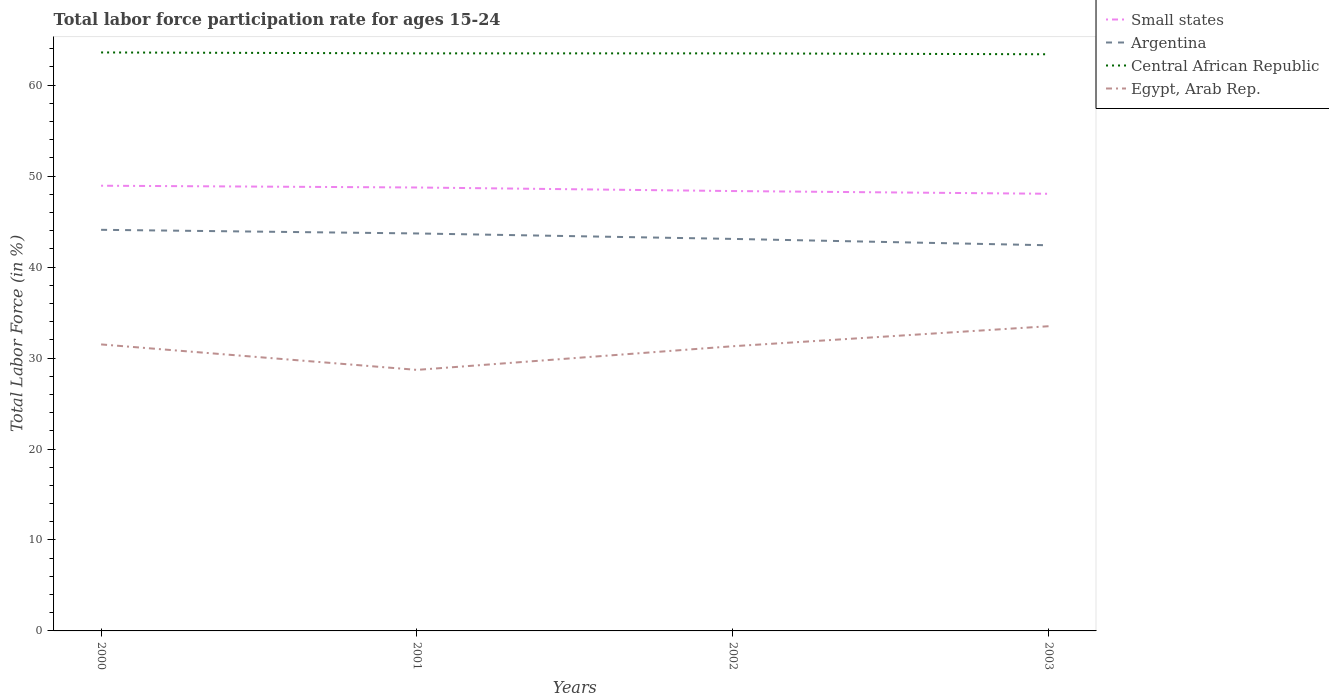How many different coloured lines are there?
Offer a terse response. 4. Does the line corresponding to Small states intersect with the line corresponding to Egypt, Arab Rep.?
Your answer should be very brief. No. Is the number of lines equal to the number of legend labels?
Make the answer very short. Yes. Across all years, what is the maximum labor force participation rate in Small states?
Offer a very short reply. 48.06. In which year was the labor force participation rate in Central African Republic maximum?
Your answer should be compact. 2003. What is the total labor force participation rate in Small states in the graph?
Your answer should be very brief. 0.59. What is the difference between the highest and the second highest labor force participation rate in Central African Republic?
Give a very brief answer. 0.2. Is the labor force participation rate in Central African Republic strictly greater than the labor force participation rate in Argentina over the years?
Your response must be concise. No. How many years are there in the graph?
Make the answer very short. 4. Are the values on the major ticks of Y-axis written in scientific E-notation?
Your answer should be compact. No. Where does the legend appear in the graph?
Offer a very short reply. Top right. How many legend labels are there?
Provide a short and direct response. 4. What is the title of the graph?
Keep it short and to the point. Total labor force participation rate for ages 15-24. What is the label or title of the X-axis?
Provide a short and direct response. Years. What is the Total Labor Force (in %) in Small states in 2000?
Make the answer very short. 48.95. What is the Total Labor Force (in %) of Argentina in 2000?
Your answer should be compact. 44.1. What is the Total Labor Force (in %) of Central African Republic in 2000?
Provide a short and direct response. 63.6. What is the Total Labor Force (in %) in Egypt, Arab Rep. in 2000?
Make the answer very short. 31.5. What is the Total Labor Force (in %) in Small states in 2001?
Keep it short and to the point. 48.75. What is the Total Labor Force (in %) of Argentina in 2001?
Give a very brief answer. 43.7. What is the Total Labor Force (in %) in Central African Republic in 2001?
Your answer should be compact. 63.5. What is the Total Labor Force (in %) of Egypt, Arab Rep. in 2001?
Your answer should be very brief. 28.7. What is the Total Labor Force (in %) in Small states in 2002?
Give a very brief answer. 48.36. What is the Total Labor Force (in %) in Argentina in 2002?
Give a very brief answer. 43.1. What is the Total Labor Force (in %) in Central African Republic in 2002?
Make the answer very short. 63.5. What is the Total Labor Force (in %) of Egypt, Arab Rep. in 2002?
Provide a short and direct response. 31.3. What is the Total Labor Force (in %) in Small states in 2003?
Your answer should be very brief. 48.06. What is the Total Labor Force (in %) in Argentina in 2003?
Provide a short and direct response. 42.4. What is the Total Labor Force (in %) in Central African Republic in 2003?
Offer a very short reply. 63.4. What is the Total Labor Force (in %) of Egypt, Arab Rep. in 2003?
Keep it short and to the point. 33.5. Across all years, what is the maximum Total Labor Force (in %) of Small states?
Ensure brevity in your answer.  48.95. Across all years, what is the maximum Total Labor Force (in %) in Argentina?
Provide a succinct answer. 44.1. Across all years, what is the maximum Total Labor Force (in %) of Central African Republic?
Your answer should be very brief. 63.6. Across all years, what is the maximum Total Labor Force (in %) of Egypt, Arab Rep.?
Your response must be concise. 33.5. Across all years, what is the minimum Total Labor Force (in %) of Small states?
Your answer should be compact. 48.06. Across all years, what is the minimum Total Labor Force (in %) in Argentina?
Your response must be concise. 42.4. Across all years, what is the minimum Total Labor Force (in %) in Central African Republic?
Ensure brevity in your answer.  63.4. Across all years, what is the minimum Total Labor Force (in %) of Egypt, Arab Rep.?
Your response must be concise. 28.7. What is the total Total Labor Force (in %) in Small states in the graph?
Offer a terse response. 194.12. What is the total Total Labor Force (in %) of Argentina in the graph?
Offer a terse response. 173.3. What is the total Total Labor Force (in %) of Central African Republic in the graph?
Offer a very short reply. 254. What is the total Total Labor Force (in %) of Egypt, Arab Rep. in the graph?
Your answer should be compact. 125. What is the difference between the Total Labor Force (in %) in Small states in 2000 and that in 2001?
Offer a terse response. 0.19. What is the difference between the Total Labor Force (in %) in Egypt, Arab Rep. in 2000 and that in 2001?
Ensure brevity in your answer.  2.8. What is the difference between the Total Labor Force (in %) of Small states in 2000 and that in 2002?
Your answer should be very brief. 0.59. What is the difference between the Total Labor Force (in %) of Central African Republic in 2000 and that in 2002?
Your answer should be very brief. 0.1. What is the difference between the Total Labor Force (in %) in Egypt, Arab Rep. in 2000 and that in 2002?
Offer a very short reply. 0.2. What is the difference between the Total Labor Force (in %) of Small states in 2000 and that in 2003?
Provide a succinct answer. 0.89. What is the difference between the Total Labor Force (in %) of Egypt, Arab Rep. in 2000 and that in 2003?
Your answer should be very brief. -2. What is the difference between the Total Labor Force (in %) in Small states in 2001 and that in 2002?
Your response must be concise. 0.39. What is the difference between the Total Labor Force (in %) in Central African Republic in 2001 and that in 2002?
Keep it short and to the point. 0. What is the difference between the Total Labor Force (in %) of Egypt, Arab Rep. in 2001 and that in 2002?
Offer a terse response. -2.6. What is the difference between the Total Labor Force (in %) of Small states in 2001 and that in 2003?
Offer a terse response. 0.69. What is the difference between the Total Labor Force (in %) of Small states in 2002 and that in 2003?
Ensure brevity in your answer.  0.3. What is the difference between the Total Labor Force (in %) in Egypt, Arab Rep. in 2002 and that in 2003?
Provide a succinct answer. -2.2. What is the difference between the Total Labor Force (in %) of Small states in 2000 and the Total Labor Force (in %) of Argentina in 2001?
Offer a terse response. 5.25. What is the difference between the Total Labor Force (in %) in Small states in 2000 and the Total Labor Force (in %) in Central African Republic in 2001?
Provide a succinct answer. -14.55. What is the difference between the Total Labor Force (in %) in Small states in 2000 and the Total Labor Force (in %) in Egypt, Arab Rep. in 2001?
Keep it short and to the point. 20.25. What is the difference between the Total Labor Force (in %) in Argentina in 2000 and the Total Labor Force (in %) in Central African Republic in 2001?
Give a very brief answer. -19.4. What is the difference between the Total Labor Force (in %) of Argentina in 2000 and the Total Labor Force (in %) of Egypt, Arab Rep. in 2001?
Provide a short and direct response. 15.4. What is the difference between the Total Labor Force (in %) in Central African Republic in 2000 and the Total Labor Force (in %) in Egypt, Arab Rep. in 2001?
Give a very brief answer. 34.9. What is the difference between the Total Labor Force (in %) in Small states in 2000 and the Total Labor Force (in %) in Argentina in 2002?
Keep it short and to the point. 5.85. What is the difference between the Total Labor Force (in %) of Small states in 2000 and the Total Labor Force (in %) of Central African Republic in 2002?
Provide a succinct answer. -14.55. What is the difference between the Total Labor Force (in %) in Small states in 2000 and the Total Labor Force (in %) in Egypt, Arab Rep. in 2002?
Your answer should be compact. 17.65. What is the difference between the Total Labor Force (in %) of Argentina in 2000 and the Total Labor Force (in %) of Central African Republic in 2002?
Keep it short and to the point. -19.4. What is the difference between the Total Labor Force (in %) in Central African Republic in 2000 and the Total Labor Force (in %) in Egypt, Arab Rep. in 2002?
Offer a terse response. 32.3. What is the difference between the Total Labor Force (in %) of Small states in 2000 and the Total Labor Force (in %) of Argentina in 2003?
Offer a very short reply. 6.55. What is the difference between the Total Labor Force (in %) in Small states in 2000 and the Total Labor Force (in %) in Central African Republic in 2003?
Provide a short and direct response. -14.45. What is the difference between the Total Labor Force (in %) of Small states in 2000 and the Total Labor Force (in %) of Egypt, Arab Rep. in 2003?
Offer a terse response. 15.45. What is the difference between the Total Labor Force (in %) in Argentina in 2000 and the Total Labor Force (in %) in Central African Republic in 2003?
Give a very brief answer. -19.3. What is the difference between the Total Labor Force (in %) of Argentina in 2000 and the Total Labor Force (in %) of Egypt, Arab Rep. in 2003?
Offer a very short reply. 10.6. What is the difference between the Total Labor Force (in %) of Central African Republic in 2000 and the Total Labor Force (in %) of Egypt, Arab Rep. in 2003?
Your answer should be very brief. 30.1. What is the difference between the Total Labor Force (in %) in Small states in 2001 and the Total Labor Force (in %) in Argentina in 2002?
Ensure brevity in your answer.  5.65. What is the difference between the Total Labor Force (in %) of Small states in 2001 and the Total Labor Force (in %) of Central African Republic in 2002?
Provide a succinct answer. -14.75. What is the difference between the Total Labor Force (in %) in Small states in 2001 and the Total Labor Force (in %) in Egypt, Arab Rep. in 2002?
Offer a terse response. 17.45. What is the difference between the Total Labor Force (in %) in Argentina in 2001 and the Total Labor Force (in %) in Central African Republic in 2002?
Your answer should be compact. -19.8. What is the difference between the Total Labor Force (in %) of Central African Republic in 2001 and the Total Labor Force (in %) of Egypt, Arab Rep. in 2002?
Make the answer very short. 32.2. What is the difference between the Total Labor Force (in %) in Small states in 2001 and the Total Labor Force (in %) in Argentina in 2003?
Your answer should be very brief. 6.35. What is the difference between the Total Labor Force (in %) of Small states in 2001 and the Total Labor Force (in %) of Central African Republic in 2003?
Give a very brief answer. -14.65. What is the difference between the Total Labor Force (in %) in Small states in 2001 and the Total Labor Force (in %) in Egypt, Arab Rep. in 2003?
Offer a very short reply. 15.25. What is the difference between the Total Labor Force (in %) in Argentina in 2001 and the Total Labor Force (in %) in Central African Republic in 2003?
Ensure brevity in your answer.  -19.7. What is the difference between the Total Labor Force (in %) in Central African Republic in 2001 and the Total Labor Force (in %) in Egypt, Arab Rep. in 2003?
Your answer should be compact. 30. What is the difference between the Total Labor Force (in %) of Small states in 2002 and the Total Labor Force (in %) of Argentina in 2003?
Ensure brevity in your answer.  5.96. What is the difference between the Total Labor Force (in %) in Small states in 2002 and the Total Labor Force (in %) in Central African Republic in 2003?
Provide a short and direct response. -15.04. What is the difference between the Total Labor Force (in %) in Small states in 2002 and the Total Labor Force (in %) in Egypt, Arab Rep. in 2003?
Your response must be concise. 14.86. What is the difference between the Total Labor Force (in %) in Argentina in 2002 and the Total Labor Force (in %) in Central African Republic in 2003?
Ensure brevity in your answer.  -20.3. What is the difference between the Total Labor Force (in %) of Argentina in 2002 and the Total Labor Force (in %) of Egypt, Arab Rep. in 2003?
Give a very brief answer. 9.6. What is the difference between the Total Labor Force (in %) of Central African Republic in 2002 and the Total Labor Force (in %) of Egypt, Arab Rep. in 2003?
Provide a succinct answer. 30. What is the average Total Labor Force (in %) in Small states per year?
Offer a terse response. 48.53. What is the average Total Labor Force (in %) of Argentina per year?
Your answer should be very brief. 43.33. What is the average Total Labor Force (in %) of Central African Republic per year?
Make the answer very short. 63.5. What is the average Total Labor Force (in %) in Egypt, Arab Rep. per year?
Keep it short and to the point. 31.25. In the year 2000, what is the difference between the Total Labor Force (in %) in Small states and Total Labor Force (in %) in Argentina?
Offer a very short reply. 4.85. In the year 2000, what is the difference between the Total Labor Force (in %) of Small states and Total Labor Force (in %) of Central African Republic?
Give a very brief answer. -14.65. In the year 2000, what is the difference between the Total Labor Force (in %) of Small states and Total Labor Force (in %) of Egypt, Arab Rep.?
Ensure brevity in your answer.  17.45. In the year 2000, what is the difference between the Total Labor Force (in %) in Argentina and Total Labor Force (in %) in Central African Republic?
Offer a very short reply. -19.5. In the year 2000, what is the difference between the Total Labor Force (in %) in Argentina and Total Labor Force (in %) in Egypt, Arab Rep.?
Your answer should be compact. 12.6. In the year 2000, what is the difference between the Total Labor Force (in %) in Central African Republic and Total Labor Force (in %) in Egypt, Arab Rep.?
Your response must be concise. 32.1. In the year 2001, what is the difference between the Total Labor Force (in %) of Small states and Total Labor Force (in %) of Argentina?
Provide a succinct answer. 5.05. In the year 2001, what is the difference between the Total Labor Force (in %) in Small states and Total Labor Force (in %) in Central African Republic?
Provide a short and direct response. -14.75. In the year 2001, what is the difference between the Total Labor Force (in %) in Small states and Total Labor Force (in %) in Egypt, Arab Rep.?
Your answer should be compact. 20.05. In the year 2001, what is the difference between the Total Labor Force (in %) of Argentina and Total Labor Force (in %) of Central African Republic?
Your answer should be compact. -19.8. In the year 2001, what is the difference between the Total Labor Force (in %) of Central African Republic and Total Labor Force (in %) of Egypt, Arab Rep.?
Give a very brief answer. 34.8. In the year 2002, what is the difference between the Total Labor Force (in %) in Small states and Total Labor Force (in %) in Argentina?
Your answer should be compact. 5.26. In the year 2002, what is the difference between the Total Labor Force (in %) in Small states and Total Labor Force (in %) in Central African Republic?
Give a very brief answer. -15.14. In the year 2002, what is the difference between the Total Labor Force (in %) in Small states and Total Labor Force (in %) in Egypt, Arab Rep.?
Keep it short and to the point. 17.06. In the year 2002, what is the difference between the Total Labor Force (in %) of Argentina and Total Labor Force (in %) of Central African Republic?
Your response must be concise. -20.4. In the year 2002, what is the difference between the Total Labor Force (in %) in Central African Republic and Total Labor Force (in %) in Egypt, Arab Rep.?
Provide a succinct answer. 32.2. In the year 2003, what is the difference between the Total Labor Force (in %) of Small states and Total Labor Force (in %) of Argentina?
Offer a terse response. 5.66. In the year 2003, what is the difference between the Total Labor Force (in %) in Small states and Total Labor Force (in %) in Central African Republic?
Your answer should be very brief. -15.34. In the year 2003, what is the difference between the Total Labor Force (in %) of Small states and Total Labor Force (in %) of Egypt, Arab Rep.?
Keep it short and to the point. 14.56. In the year 2003, what is the difference between the Total Labor Force (in %) of Argentina and Total Labor Force (in %) of Central African Republic?
Your answer should be very brief. -21. In the year 2003, what is the difference between the Total Labor Force (in %) of Argentina and Total Labor Force (in %) of Egypt, Arab Rep.?
Provide a short and direct response. 8.9. In the year 2003, what is the difference between the Total Labor Force (in %) in Central African Republic and Total Labor Force (in %) in Egypt, Arab Rep.?
Provide a succinct answer. 29.9. What is the ratio of the Total Labor Force (in %) in Small states in 2000 to that in 2001?
Offer a terse response. 1. What is the ratio of the Total Labor Force (in %) in Argentina in 2000 to that in 2001?
Your response must be concise. 1.01. What is the ratio of the Total Labor Force (in %) of Central African Republic in 2000 to that in 2001?
Your answer should be very brief. 1. What is the ratio of the Total Labor Force (in %) of Egypt, Arab Rep. in 2000 to that in 2001?
Provide a succinct answer. 1.1. What is the ratio of the Total Labor Force (in %) of Small states in 2000 to that in 2002?
Make the answer very short. 1.01. What is the ratio of the Total Labor Force (in %) in Argentina in 2000 to that in 2002?
Your answer should be very brief. 1.02. What is the ratio of the Total Labor Force (in %) of Egypt, Arab Rep. in 2000 to that in 2002?
Your answer should be very brief. 1.01. What is the ratio of the Total Labor Force (in %) of Small states in 2000 to that in 2003?
Your answer should be compact. 1.02. What is the ratio of the Total Labor Force (in %) in Argentina in 2000 to that in 2003?
Offer a terse response. 1.04. What is the ratio of the Total Labor Force (in %) in Central African Republic in 2000 to that in 2003?
Give a very brief answer. 1. What is the ratio of the Total Labor Force (in %) of Egypt, Arab Rep. in 2000 to that in 2003?
Ensure brevity in your answer.  0.94. What is the ratio of the Total Labor Force (in %) in Argentina in 2001 to that in 2002?
Keep it short and to the point. 1.01. What is the ratio of the Total Labor Force (in %) of Egypt, Arab Rep. in 2001 to that in 2002?
Your response must be concise. 0.92. What is the ratio of the Total Labor Force (in %) in Small states in 2001 to that in 2003?
Provide a succinct answer. 1.01. What is the ratio of the Total Labor Force (in %) of Argentina in 2001 to that in 2003?
Offer a terse response. 1.03. What is the ratio of the Total Labor Force (in %) of Central African Republic in 2001 to that in 2003?
Ensure brevity in your answer.  1. What is the ratio of the Total Labor Force (in %) in Egypt, Arab Rep. in 2001 to that in 2003?
Give a very brief answer. 0.86. What is the ratio of the Total Labor Force (in %) in Argentina in 2002 to that in 2003?
Give a very brief answer. 1.02. What is the ratio of the Total Labor Force (in %) in Central African Republic in 2002 to that in 2003?
Provide a short and direct response. 1. What is the ratio of the Total Labor Force (in %) of Egypt, Arab Rep. in 2002 to that in 2003?
Make the answer very short. 0.93. What is the difference between the highest and the second highest Total Labor Force (in %) of Small states?
Offer a very short reply. 0.19. What is the difference between the highest and the second highest Total Labor Force (in %) of Egypt, Arab Rep.?
Give a very brief answer. 2. What is the difference between the highest and the lowest Total Labor Force (in %) of Small states?
Make the answer very short. 0.89. What is the difference between the highest and the lowest Total Labor Force (in %) in Central African Republic?
Offer a very short reply. 0.2. 